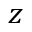<formula> <loc_0><loc_0><loc_500><loc_500>z</formula> 